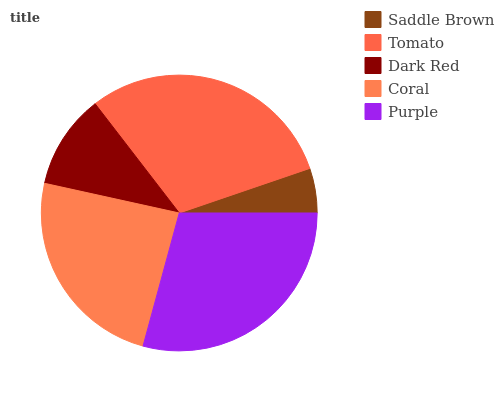Is Saddle Brown the minimum?
Answer yes or no. Yes. Is Tomato the maximum?
Answer yes or no. Yes. Is Dark Red the minimum?
Answer yes or no. No. Is Dark Red the maximum?
Answer yes or no. No. Is Tomato greater than Dark Red?
Answer yes or no. Yes. Is Dark Red less than Tomato?
Answer yes or no. Yes. Is Dark Red greater than Tomato?
Answer yes or no. No. Is Tomato less than Dark Red?
Answer yes or no. No. Is Coral the high median?
Answer yes or no. Yes. Is Coral the low median?
Answer yes or no. Yes. Is Saddle Brown the high median?
Answer yes or no. No. Is Tomato the low median?
Answer yes or no. No. 